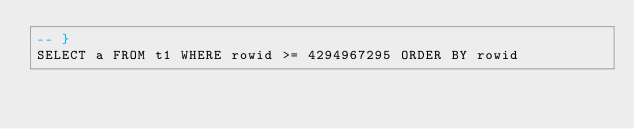<code> <loc_0><loc_0><loc_500><loc_500><_SQL_>-- }
SELECT a FROM t1 WHERE rowid >= 4294967295 ORDER BY rowid</code> 